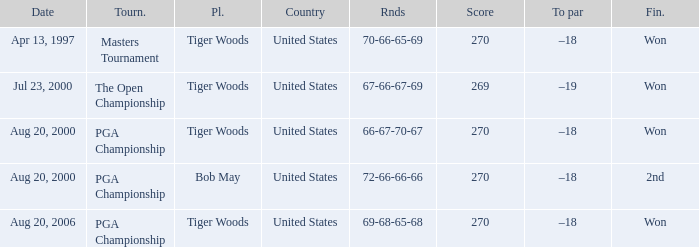What country hosts the tournament the open championship? United States. 